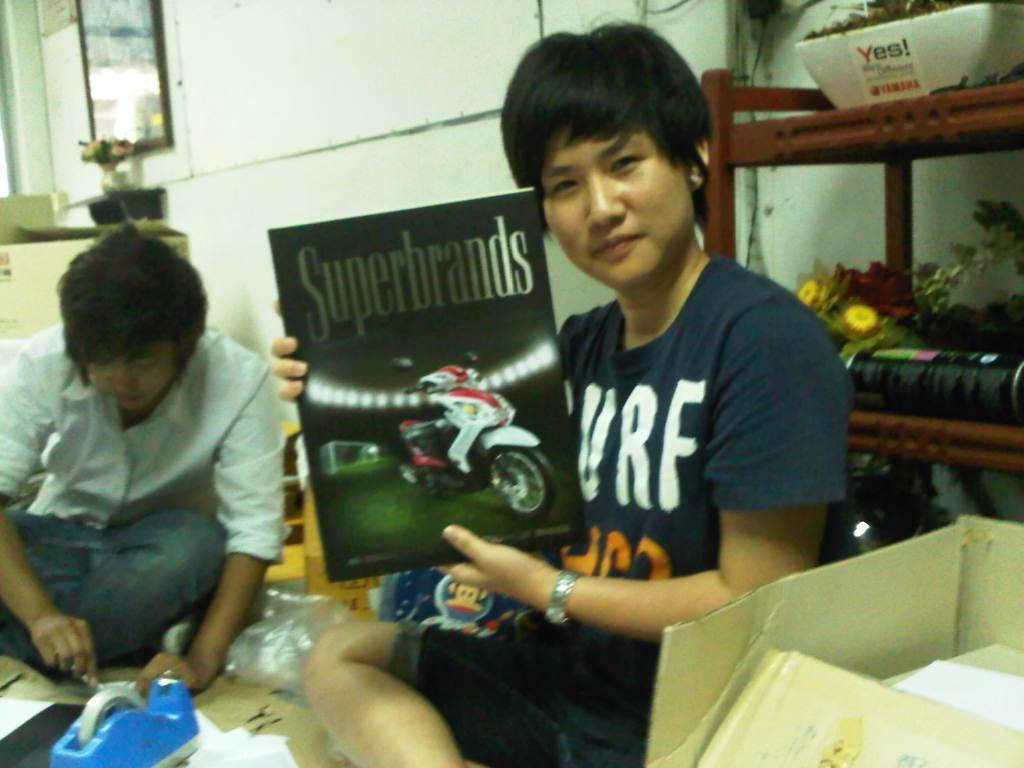Can you describe this image briefly? In this image I can see a person sitting and holding a board or a book. There is another person sitting and holding some objects. There are cardboard boxes, flowers and there is a mirror attached to the wall. Also there are some other objects. 